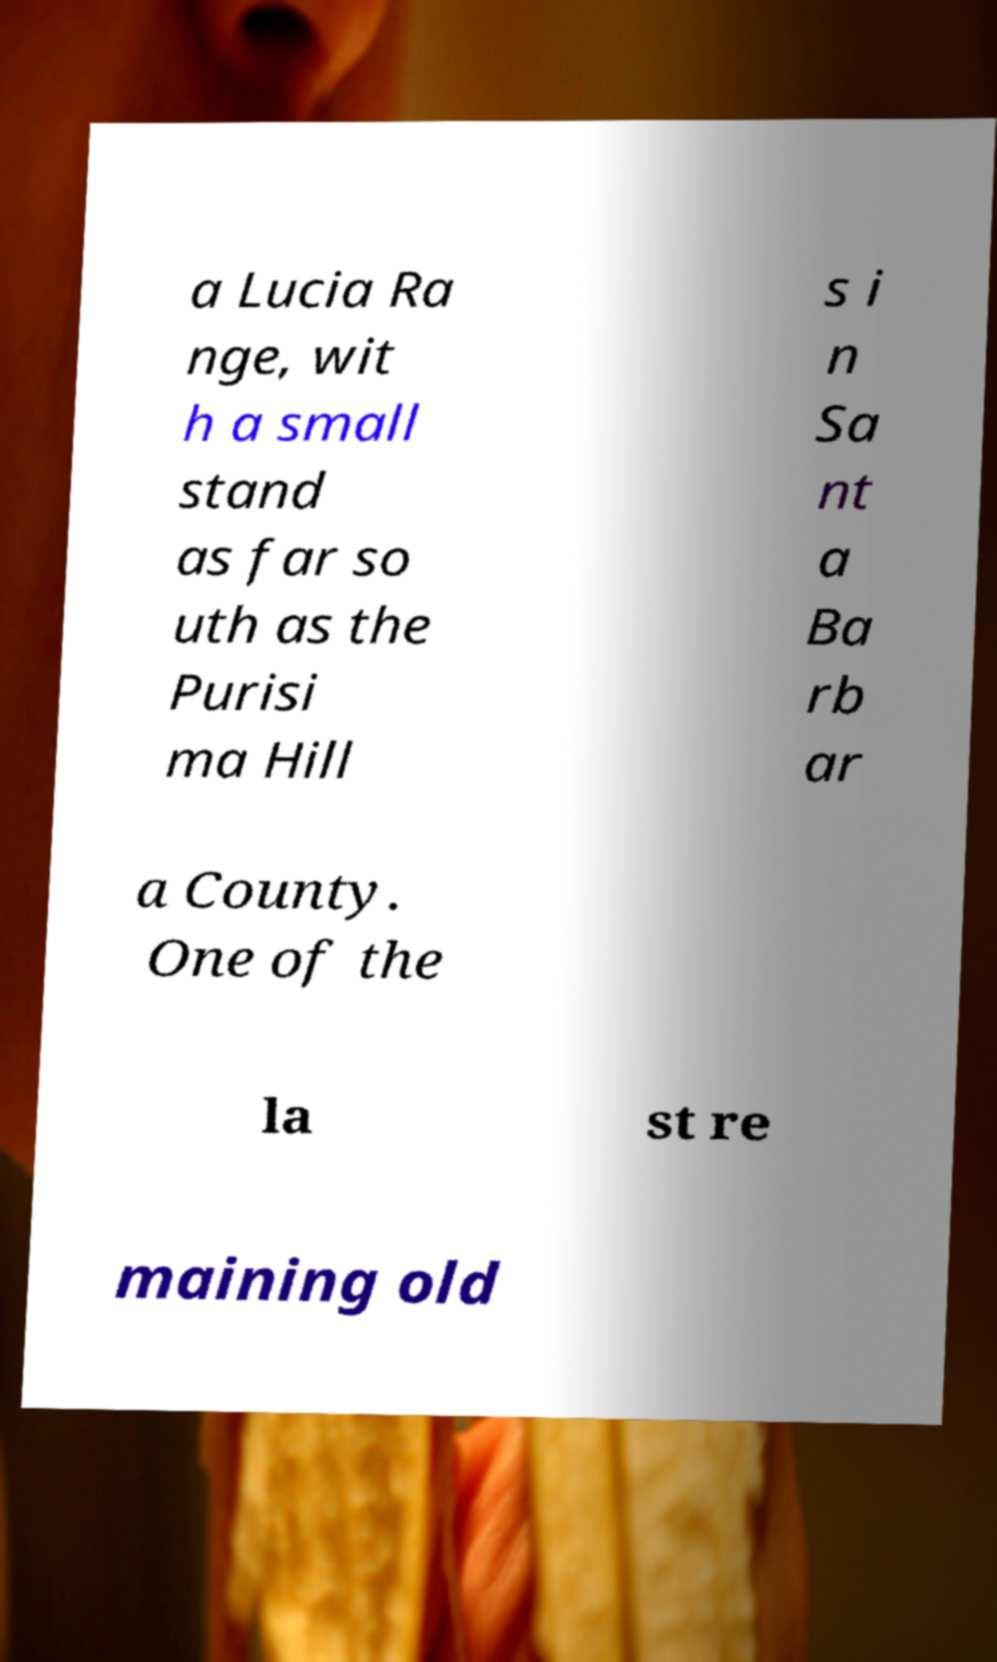There's text embedded in this image that I need extracted. Can you transcribe it verbatim? a Lucia Ra nge, wit h a small stand as far so uth as the Purisi ma Hill s i n Sa nt a Ba rb ar a County. One of the la st re maining old 